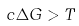Convert formula to latex. <formula><loc_0><loc_0><loc_500><loc_500>c \Delta G > T</formula> 